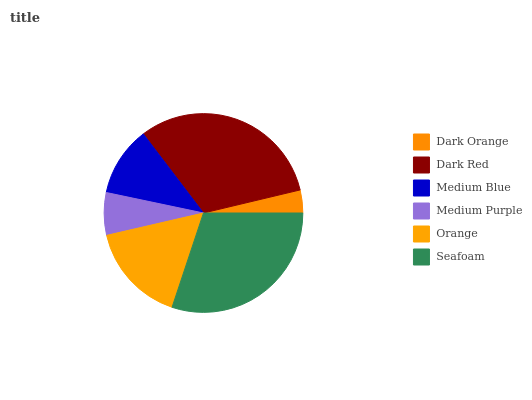Is Dark Orange the minimum?
Answer yes or no. Yes. Is Dark Red the maximum?
Answer yes or no. Yes. Is Medium Blue the minimum?
Answer yes or no. No. Is Medium Blue the maximum?
Answer yes or no. No. Is Dark Red greater than Medium Blue?
Answer yes or no. Yes. Is Medium Blue less than Dark Red?
Answer yes or no. Yes. Is Medium Blue greater than Dark Red?
Answer yes or no. No. Is Dark Red less than Medium Blue?
Answer yes or no. No. Is Orange the high median?
Answer yes or no. Yes. Is Medium Blue the low median?
Answer yes or no. Yes. Is Dark Orange the high median?
Answer yes or no. No. Is Dark Red the low median?
Answer yes or no. No. 